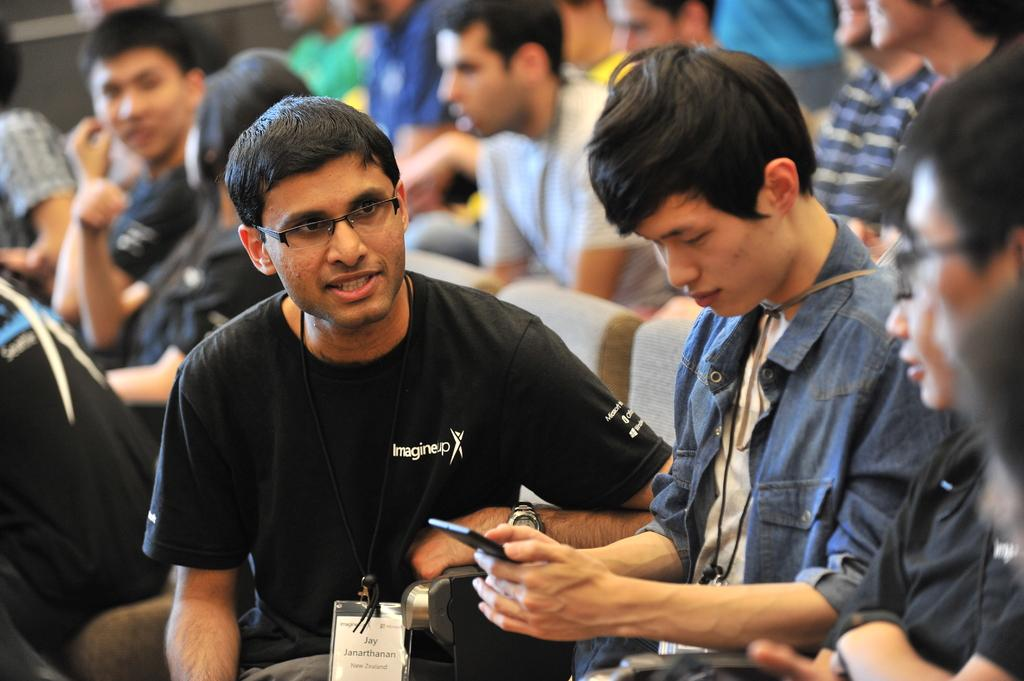What are the people in the image doing? The people in the image are sitting on chairs. Can you describe any objects that the people are holding? Yes, there is a person holding a cell phone in the image. What can be observed about the background of the image? The background of the image is blurred. Where is the crib located in the image? There is no crib present in the image. What type of oven is visible in the image? There is no oven present in the image. 